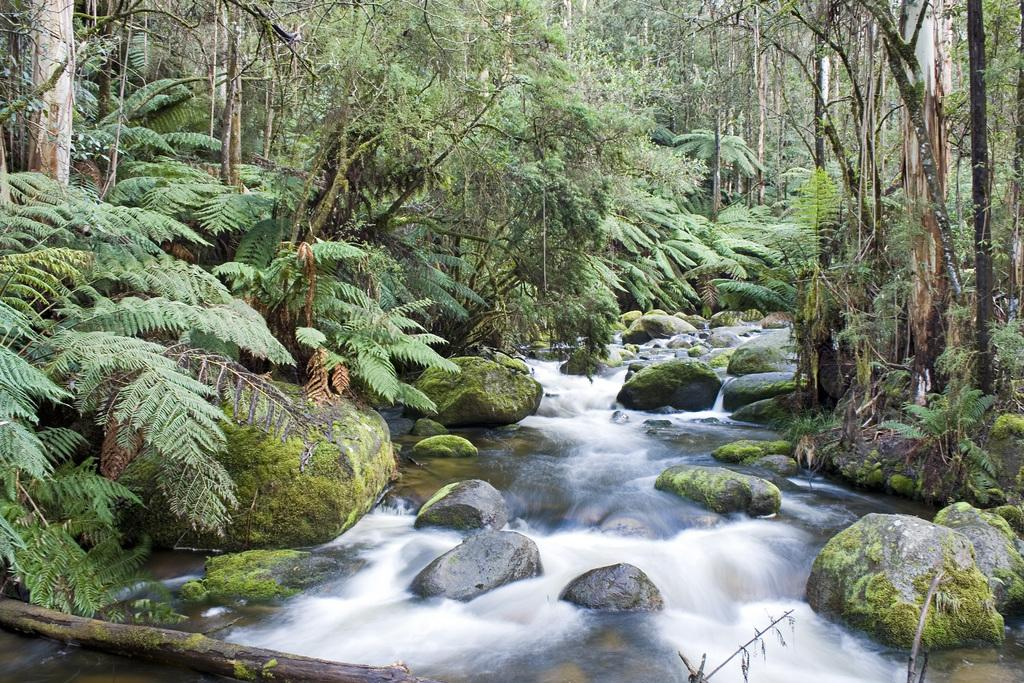What type of natural feature is present in the image? There is a river in the image. What is the river doing in the image? The river is flowing in the image. What type of environment surrounds the river? The river is surrounded by a forest. What can be found within the forest? Trees are present in the forest. What other objects can be seen in the image? Rocks are visible in the image. How many slaves are visible in the image? There are no slaves present in the image; it features a flowing river surrounded by a forest. 